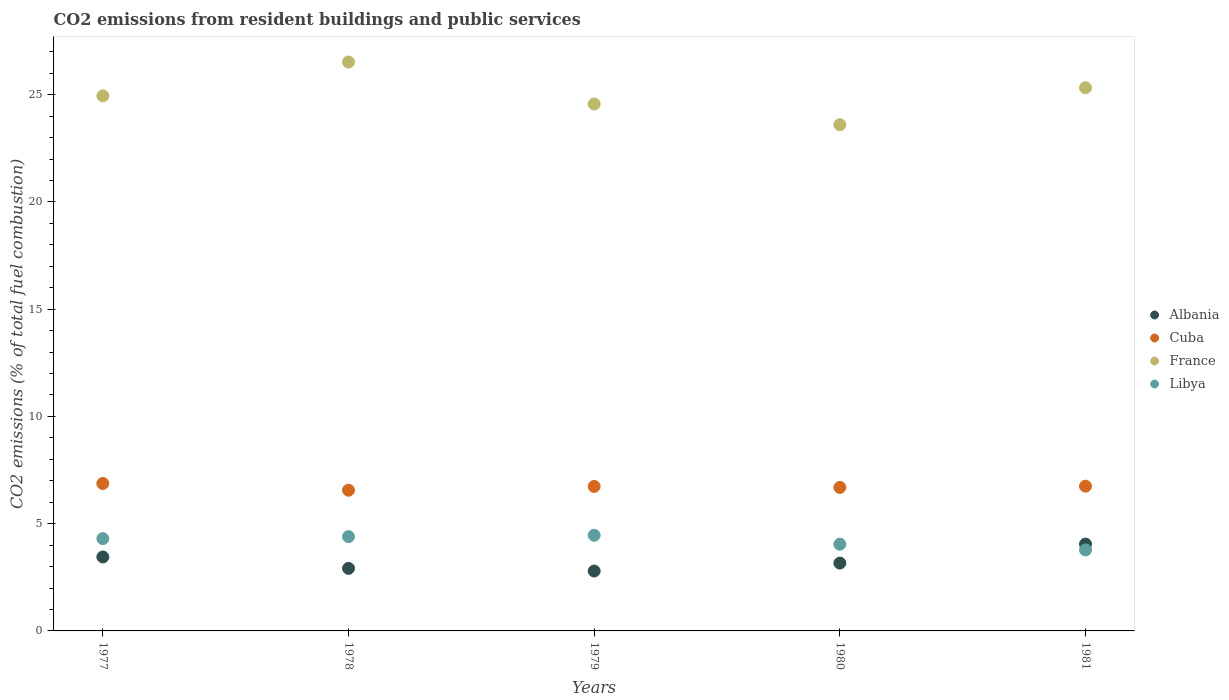Is the number of dotlines equal to the number of legend labels?
Keep it short and to the point. Yes. What is the total CO2 emitted in Cuba in 1979?
Your response must be concise. 6.74. Across all years, what is the maximum total CO2 emitted in Albania?
Offer a terse response. 4.05. Across all years, what is the minimum total CO2 emitted in Albania?
Provide a short and direct response. 2.79. In which year was the total CO2 emitted in France maximum?
Provide a succinct answer. 1978. In which year was the total CO2 emitted in Cuba minimum?
Offer a very short reply. 1978. What is the total total CO2 emitted in Libya in the graph?
Keep it short and to the point. 20.98. What is the difference between the total CO2 emitted in Libya in 1979 and that in 1980?
Ensure brevity in your answer.  0.42. What is the difference between the total CO2 emitted in Libya in 1981 and the total CO2 emitted in Albania in 1980?
Ensure brevity in your answer.  0.61. What is the average total CO2 emitted in France per year?
Your response must be concise. 24.99. In the year 1978, what is the difference between the total CO2 emitted in Albania and total CO2 emitted in Cuba?
Make the answer very short. -3.64. What is the ratio of the total CO2 emitted in France in 1979 to that in 1980?
Offer a very short reply. 1.04. What is the difference between the highest and the second highest total CO2 emitted in Libya?
Make the answer very short. 0.06. What is the difference between the highest and the lowest total CO2 emitted in Libya?
Your answer should be compact. 0.68. In how many years, is the total CO2 emitted in Libya greater than the average total CO2 emitted in Libya taken over all years?
Offer a terse response. 3. Is the sum of the total CO2 emitted in Cuba in 1979 and 1980 greater than the maximum total CO2 emitted in France across all years?
Your answer should be very brief. No. Does the total CO2 emitted in Albania monotonically increase over the years?
Give a very brief answer. No. How many dotlines are there?
Keep it short and to the point. 4. How many years are there in the graph?
Offer a terse response. 5. Are the values on the major ticks of Y-axis written in scientific E-notation?
Your answer should be compact. No. Does the graph contain any zero values?
Make the answer very short. No. How many legend labels are there?
Your answer should be compact. 4. How are the legend labels stacked?
Ensure brevity in your answer.  Vertical. What is the title of the graph?
Provide a short and direct response. CO2 emissions from resident buildings and public services. What is the label or title of the Y-axis?
Give a very brief answer. CO2 emissions (% of total fuel combustion). What is the CO2 emissions (% of total fuel combustion) of Albania in 1977?
Keep it short and to the point. 3.45. What is the CO2 emissions (% of total fuel combustion) of Cuba in 1977?
Keep it short and to the point. 6.88. What is the CO2 emissions (% of total fuel combustion) in France in 1977?
Your answer should be very brief. 24.95. What is the CO2 emissions (% of total fuel combustion) of Libya in 1977?
Make the answer very short. 4.3. What is the CO2 emissions (% of total fuel combustion) of Albania in 1978?
Your answer should be compact. 2.92. What is the CO2 emissions (% of total fuel combustion) in Cuba in 1978?
Provide a short and direct response. 6.56. What is the CO2 emissions (% of total fuel combustion) in France in 1978?
Your answer should be compact. 26.52. What is the CO2 emissions (% of total fuel combustion) of Libya in 1978?
Keep it short and to the point. 4.39. What is the CO2 emissions (% of total fuel combustion) of Albania in 1979?
Offer a very short reply. 2.79. What is the CO2 emissions (% of total fuel combustion) of Cuba in 1979?
Ensure brevity in your answer.  6.74. What is the CO2 emissions (% of total fuel combustion) of France in 1979?
Offer a terse response. 24.57. What is the CO2 emissions (% of total fuel combustion) in Libya in 1979?
Your answer should be very brief. 4.46. What is the CO2 emissions (% of total fuel combustion) in Albania in 1980?
Ensure brevity in your answer.  3.16. What is the CO2 emissions (% of total fuel combustion) of Cuba in 1980?
Ensure brevity in your answer.  6.69. What is the CO2 emissions (% of total fuel combustion) of France in 1980?
Ensure brevity in your answer.  23.6. What is the CO2 emissions (% of total fuel combustion) in Libya in 1980?
Offer a terse response. 4.04. What is the CO2 emissions (% of total fuel combustion) in Albania in 1981?
Make the answer very short. 4.05. What is the CO2 emissions (% of total fuel combustion) in Cuba in 1981?
Offer a terse response. 6.75. What is the CO2 emissions (% of total fuel combustion) in France in 1981?
Offer a terse response. 25.33. What is the CO2 emissions (% of total fuel combustion) of Libya in 1981?
Keep it short and to the point. 3.78. Across all years, what is the maximum CO2 emissions (% of total fuel combustion) in Albania?
Your answer should be very brief. 4.05. Across all years, what is the maximum CO2 emissions (% of total fuel combustion) of Cuba?
Provide a succinct answer. 6.88. Across all years, what is the maximum CO2 emissions (% of total fuel combustion) in France?
Give a very brief answer. 26.52. Across all years, what is the maximum CO2 emissions (% of total fuel combustion) of Libya?
Ensure brevity in your answer.  4.46. Across all years, what is the minimum CO2 emissions (% of total fuel combustion) in Albania?
Your answer should be compact. 2.79. Across all years, what is the minimum CO2 emissions (% of total fuel combustion) of Cuba?
Your answer should be very brief. 6.56. Across all years, what is the minimum CO2 emissions (% of total fuel combustion) of France?
Your answer should be compact. 23.6. Across all years, what is the minimum CO2 emissions (% of total fuel combustion) in Libya?
Your answer should be very brief. 3.78. What is the total CO2 emissions (% of total fuel combustion) in Albania in the graph?
Your answer should be compact. 16.37. What is the total CO2 emissions (% of total fuel combustion) in Cuba in the graph?
Make the answer very short. 33.61. What is the total CO2 emissions (% of total fuel combustion) of France in the graph?
Your answer should be very brief. 124.97. What is the total CO2 emissions (% of total fuel combustion) of Libya in the graph?
Give a very brief answer. 20.98. What is the difference between the CO2 emissions (% of total fuel combustion) of Albania in 1977 and that in 1978?
Provide a short and direct response. 0.53. What is the difference between the CO2 emissions (% of total fuel combustion) in Cuba in 1977 and that in 1978?
Your answer should be very brief. 0.31. What is the difference between the CO2 emissions (% of total fuel combustion) in France in 1977 and that in 1978?
Offer a terse response. -1.58. What is the difference between the CO2 emissions (% of total fuel combustion) of Libya in 1977 and that in 1978?
Your response must be concise. -0.09. What is the difference between the CO2 emissions (% of total fuel combustion) in Albania in 1977 and that in 1979?
Offer a terse response. 0.66. What is the difference between the CO2 emissions (% of total fuel combustion) of Cuba in 1977 and that in 1979?
Offer a very short reply. 0.14. What is the difference between the CO2 emissions (% of total fuel combustion) of France in 1977 and that in 1979?
Give a very brief answer. 0.38. What is the difference between the CO2 emissions (% of total fuel combustion) in Libya in 1977 and that in 1979?
Offer a very short reply. -0.16. What is the difference between the CO2 emissions (% of total fuel combustion) of Albania in 1977 and that in 1980?
Ensure brevity in your answer.  0.29. What is the difference between the CO2 emissions (% of total fuel combustion) of Cuba in 1977 and that in 1980?
Your answer should be compact. 0.18. What is the difference between the CO2 emissions (% of total fuel combustion) of France in 1977 and that in 1980?
Offer a terse response. 1.34. What is the difference between the CO2 emissions (% of total fuel combustion) of Libya in 1977 and that in 1980?
Provide a succinct answer. 0.26. What is the difference between the CO2 emissions (% of total fuel combustion) in Albania in 1977 and that in 1981?
Provide a short and direct response. -0.6. What is the difference between the CO2 emissions (% of total fuel combustion) in Cuba in 1977 and that in 1981?
Keep it short and to the point. 0.13. What is the difference between the CO2 emissions (% of total fuel combustion) in France in 1977 and that in 1981?
Offer a very short reply. -0.38. What is the difference between the CO2 emissions (% of total fuel combustion) in Libya in 1977 and that in 1981?
Your answer should be compact. 0.53. What is the difference between the CO2 emissions (% of total fuel combustion) of Albania in 1978 and that in 1979?
Offer a very short reply. 0.12. What is the difference between the CO2 emissions (% of total fuel combustion) of Cuba in 1978 and that in 1979?
Your response must be concise. -0.18. What is the difference between the CO2 emissions (% of total fuel combustion) of France in 1978 and that in 1979?
Provide a succinct answer. 1.96. What is the difference between the CO2 emissions (% of total fuel combustion) in Libya in 1978 and that in 1979?
Your response must be concise. -0.06. What is the difference between the CO2 emissions (% of total fuel combustion) of Albania in 1978 and that in 1980?
Your answer should be very brief. -0.24. What is the difference between the CO2 emissions (% of total fuel combustion) in Cuba in 1978 and that in 1980?
Provide a succinct answer. -0.13. What is the difference between the CO2 emissions (% of total fuel combustion) in France in 1978 and that in 1980?
Your response must be concise. 2.92. What is the difference between the CO2 emissions (% of total fuel combustion) of Libya in 1978 and that in 1980?
Your response must be concise. 0.35. What is the difference between the CO2 emissions (% of total fuel combustion) in Albania in 1978 and that in 1981?
Your answer should be compact. -1.13. What is the difference between the CO2 emissions (% of total fuel combustion) of Cuba in 1978 and that in 1981?
Your response must be concise. -0.19. What is the difference between the CO2 emissions (% of total fuel combustion) in France in 1978 and that in 1981?
Offer a very short reply. 1.2. What is the difference between the CO2 emissions (% of total fuel combustion) of Libya in 1978 and that in 1981?
Offer a very short reply. 0.62. What is the difference between the CO2 emissions (% of total fuel combustion) in Albania in 1979 and that in 1980?
Your response must be concise. -0.37. What is the difference between the CO2 emissions (% of total fuel combustion) of Cuba in 1979 and that in 1980?
Your response must be concise. 0.05. What is the difference between the CO2 emissions (% of total fuel combustion) of France in 1979 and that in 1980?
Offer a very short reply. 0.96. What is the difference between the CO2 emissions (% of total fuel combustion) in Libya in 1979 and that in 1980?
Provide a succinct answer. 0.42. What is the difference between the CO2 emissions (% of total fuel combustion) of Albania in 1979 and that in 1981?
Keep it short and to the point. -1.26. What is the difference between the CO2 emissions (% of total fuel combustion) of Cuba in 1979 and that in 1981?
Keep it short and to the point. -0.01. What is the difference between the CO2 emissions (% of total fuel combustion) of France in 1979 and that in 1981?
Offer a terse response. -0.76. What is the difference between the CO2 emissions (% of total fuel combustion) in Libya in 1979 and that in 1981?
Your answer should be compact. 0.68. What is the difference between the CO2 emissions (% of total fuel combustion) of Albania in 1980 and that in 1981?
Offer a very short reply. -0.89. What is the difference between the CO2 emissions (% of total fuel combustion) of Cuba in 1980 and that in 1981?
Ensure brevity in your answer.  -0.06. What is the difference between the CO2 emissions (% of total fuel combustion) of France in 1980 and that in 1981?
Offer a very short reply. -1.72. What is the difference between the CO2 emissions (% of total fuel combustion) of Libya in 1980 and that in 1981?
Provide a succinct answer. 0.27. What is the difference between the CO2 emissions (% of total fuel combustion) in Albania in 1977 and the CO2 emissions (% of total fuel combustion) in Cuba in 1978?
Ensure brevity in your answer.  -3.11. What is the difference between the CO2 emissions (% of total fuel combustion) of Albania in 1977 and the CO2 emissions (% of total fuel combustion) of France in 1978?
Ensure brevity in your answer.  -23.08. What is the difference between the CO2 emissions (% of total fuel combustion) of Albania in 1977 and the CO2 emissions (% of total fuel combustion) of Libya in 1978?
Keep it short and to the point. -0.95. What is the difference between the CO2 emissions (% of total fuel combustion) in Cuba in 1977 and the CO2 emissions (% of total fuel combustion) in France in 1978?
Keep it short and to the point. -19.65. What is the difference between the CO2 emissions (% of total fuel combustion) of Cuba in 1977 and the CO2 emissions (% of total fuel combustion) of Libya in 1978?
Give a very brief answer. 2.48. What is the difference between the CO2 emissions (% of total fuel combustion) of France in 1977 and the CO2 emissions (% of total fuel combustion) of Libya in 1978?
Give a very brief answer. 20.55. What is the difference between the CO2 emissions (% of total fuel combustion) in Albania in 1977 and the CO2 emissions (% of total fuel combustion) in Cuba in 1979?
Your answer should be compact. -3.29. What is the difference between the CO2 emissions (% of total fuel combustion) of Albania in 1977 and the CO2 emissions (% of total fuel combustion) of France in 1979?
Provide a short and direct response. -21.12. What is the difference between the CO2 emissions (% of total fuel combustion) in Albania in 1977 and the CO2 emissions (% of total fuel combustion) in Libya in 1979?
Provide a succinct answer. -1.01. What is the difference between the CO2 emissions (% of total fuel combustion) in Cuba in 1977 and the CO2 emissions (% of total fuel combustion) in France in 1979?
Make the answer very short. -17.69. What is the difference between the CO2 emissions (% of total fuel combustion) in Cuba in 1977 and the CO2 emissions (% of total fuel combustion) in Libya in 1979?
Provide a short and direct response. 2.42. What is the difference between the CO2 emissions (% of total fuel combustion) of France in 1977 and the CO2 emissions (% of total fuel combustion) of Libya in 1979?
Your answer should be compact. 20.49. What is the difference between the CO2 emissions (% of total fuel combustion) of Albania in 1977 and the CO2 emissions (% of total fuel combustion) of Cuba in 1980?
Your answer should be compact. -3.24. What is the difference between the CO2 emissions (% of total fuel combustion) in Albania in 1977 and the CO2 emissions (% of total fuel combustion) in France in 1980?
Offer a terse response. -20.15. What is the difference between the CO2 emissions (% of total fuel combustion) of Albania in 1977 and the CO2 emissions (% of total fuel combustion) of Libya in 1980?
Give a very brief answer. -0.59. What is the difference between the CO2 emissions (% of total fuel combustion) of Cuba in 1977 and the CO2 emissions (% of total fuel combustion) of France in 1980?
Offer a very short reply. -16.73. What is the difference between the CO2 emissions (% of total fuel combustion) in Cuba in 1977 and the CO2 emissions (% of total fuel combustion) in Libya in 1980?
Make the answer very short. 2.83. What is the difference between the CO2 emissions (% of total fuel combustion) in France in 1977 and the CO2 emissions (% of total fuel combustion) in Libya in 1980?
Offer a terse response. 20.9. What is the difference between the CO2 emissions (% of total fuel combustion) of Albania in 1977 and the CO2 emissions (% of total fuel combustion) of Cuba in 1981?
Ensure brevity in your answer.  -3.3. What is the difference between the CO2 emissions (% of total fuel combustion) in Albania in 1977 and the CO2 emissions (% of total fuel combustion) in France in 1981?
Keep it short and to the point. -21.88. What is the difference between the CO2 emissions (% of total fuel combustion) in Albania in 1977 and the CO2 emissions (% of total fuel combustion) in Libya in 1981?
Provide a succinct answer. -0.33. What is the difference between the CO2 emissions (% of total fuel combustion) in Cuba in 1977 and the CO2 emissions (% of total fuel combustion) in France in 1981?
Your answer should be very brief. -18.45. What is the difference between the CO2 emissions (% of total fuel combustion) in Cuba in 1977 and the CO2 emissions (% of total fuel combustion) in Libya in 1981?
Provide a short and direct response. 3.1. What is the difference between the CO2 emissions (% of total fuel combustion) of France in 1977 and the CO2 emissions (% of total fuel combustion) of Libya in 1981?
Keep it short and to the point. 21.17. What is the difference between the CO2 emissions (% of total fuel combustion) in Albania in 1978 and the CO2 emissions (% of total fuel combustion) in Cuba in 1979?
Keep it short and to the point. -3.82. What is the difference between the CO2 emissions (% of total fuel combustion) in Albania in 1978 and the CO2 emissions (% of total fuel combustion) in France in 1979?
Offer a very short reply. -21.65. What is the difference between the CO2 emissions (% of total fuel combustion) in Albania in 1978 and the CO2 emissions (% of total fuel combustion) in Libya in 1979?
Offer a very short reply. -1.54. What is the difference between the CO2 emissions (% of total fuel combustion) in Cuba in 1978 and the CO2 emissions (% of total fuel combustion) in France in 1979?
Make the answer very short. -18.01. What is the difference between the CO2 emissions (% of total fuel combustion) of Cuba in 1978 and the CO2 emissions (% of total fuel combustion) of Libya in 1979?
Your answer should be very brief. 2.1. What is the difference between the CO2 emissions (% of total fuel combustion) of France in 1978 and the CO2 emissions (% of total fuel combustion) of Libya in 1979?
Make the answer very short. 22.07. What is the difference between the CO2 emissions (% of total fuel combustion) of Albania in 1978 and the CO2 emissions (% of total fuel combustion) of Cuba in 1980?
Offer a terse response. -3.77. What is the difference between the CO2 emissions (% of total fuel combustion) in Albania in 1978 and the CO2 emissions (% of total fuel combustion) in France in 1980?
Your answer should be very brief. -20.69. What is the difference between the CO2 emissions (% of total fuel combustion) of Albania in 1978 and the CO2 emissions (% of total fuel combustion) of Libya in 1980?
Your answer should be very brief. -1.13. What is the difference between the CO2 emissions (% of total fuel combustion) in Cuba in 1978 and the CO2 emissions (% of total fuel combustion) in France in 1980?
Your response must be concise. -17.04. What is the difference between the CO2 emissions (% of total fuel combustion) of Cuba in 1978 and the CO2 emissions (% of total fuel combustion) of Libya in 1980?
Offer a terse response. 2.52. What is the difference between the CO2 emissions (% of total fuel combustion) of France in 1978 and the CO2 emissions (% of total fuel combustion) of Libya in 1980?
Provide a short and direct response. 22.48. What is the difference between the CO2 emissions (% of total fuel combustion) in Albania in 1978 and the CO2 emissions (% of total fuel combustion) in Cuba in 1981?
Provide a short and direct response. -3.83. What is the difference between the CO2 emissions (% of total fuel combustion) of Albania in 1978 and the CO2 emissions (% of total fuel combustion) of France in 1981?
Provide a succinct answer. -22.41. What is the difference between the CO2 emissions (% of total fuel combustion) in Albania in 1978 and the CO2 emissions (% of total fuel combustion) in Libya in 1981?
Keep it short and to the point. -0.86. What is the difference between the CO2 emissions (% of total fuel combustion) in Cuba in 1978 and the CO2 emissions (% of total fuel combustion) in France in 1981?
Offer a very short reply. -18.77. What is the difference between the CO2 emissions (% of total fuel combustion) of Cuba in 1978 and the CO2 emissions (% of total fuel combustion) of Libya in 1981?
Provide a short and direct response. 2.78. What is the difference between the CO2 emissions (% of total fuel combustion) in France in 1978 and the CO2 emissions (% of total fuel combustion) in Libya in 1981?
Offer a very short reply. 22.75. What is the difference between the CO2 emissions (% of total fuel combustion) of Albania in 1979 and the CO2 emissions (% of total fuel combustion) of Cuba in 1980?
Your answer should be very brief. -3.9. What is the difference between the CO2 emissions (% of total fuel combustion) in Albania in 1979 and the CO2 emissions (% of total fuel combustion) in France in 1980?
Your response must be concise. -20.81. What is the difference between the CO2 emissions (% of total fuel combustion) of Albania in 1979 and the CO2 emissions (% of total fuel combustion) of Libya in 1980?
Offer a very short reply. -1.25. What is the difference between the CO2 emissions (% of total fuel combustion) in Cuba in 1979 and the CO2 emissions (% of total fuel combustion) in France in 1980?
Provide a succinct answer. -16.87. What is the difference between the CO2 emissions (% of total fuel combustion) in Cuba in 1979 and the CO2 emissions (% of total fuel combustion) in Libya in 1980?
Offer a very short reply. 2.69. What is the difference between the CO2 emissions (% of total fuel combustion) in France in 1979 and the CO2 emissions (% of total fuel combustion) in Libya in 1980?
Provide a short and direct response. 20.52. What is the difference between the CO2 emissions (% of total fuel combustion) of Albania in 1979 and the CO2 emissions (% of total fuel combustion) of Cuba in 1981?
Provide a succinct answer. -3.96. What is the difference between the CO2 emissions (% of total fuel combustion) of Albania in 1979 and the CO2 emissions (% of total fuel combustion) of France in 1981?
Provide a short and direct response. -22.53. What is the difference between the CO2 emissions (% of total fuel combustion) of Albania in 1979 and the CO2 emissions (% of total fuel combustion) of Libya in 1981?
Ensure brevity in your answer.  -0.98. What is the difference between the CO2 emissions (% of total fuel combustion) in Cuba in 1979 and the CO2 emissions (% of total fuel combustion) in France in 1981?
Your response must be concise. -18.59. What is the difference between the CO2 emissions (% of total fuel combustion) in Cuba in 1979 and the CO2 emissions (% of total fuel combustion) in Libya in 1981?
Your answer should be compact. 2.96. What is the difference between the CO2 emissions (% of total fuel combustion) in France in 1979 and the CO2 emissions (% of total fuel combustion) in Libya in 1981?
Your answer should be compact. 20.79. What is the difference between the CO2 emissions (% of total fuel combustion) in Albania in 1980 and the CO2 emissions (% of total fuel combustion) in Cuba in 1981?
Give a very brief answer. -3.59. What is the difference between the CO2 emissions (% of total fuel combustion) of Albania in 1980 and the CO2 emissions (% of total fuel combustion) of France in 1981?
Your answer should be compact. -22.16. What is the difference between the CO2 emissions (% of total fuel combustion) of Albania in 1980 and the CO2 emissions (% of total fuel combustion) of Libya in 1981?
Make the answer very short. -0.61. What is the difference between the CO2 emissions (% of total fuel combustion) of Cuba in 1980 and the CO2 emissions (% of total fuel combustion) of France in 1981?
Offer a very short reply. -18.64. What is the difference between the CO2 emissions (% of total fuel combustion) in Cuba in 1980 and the CO2 emissions (% of total fuel combustion) in Libya in 1981?
Offer a terse response. 2.92. What is the difference between the CO2 emissions (% of total fuel combustion) of France in 1980 and the CO2 emissions (% of total fuel combustion) of Libya in 1981?
Your answer should be very brief. 19.83. What is the average CO2 emissions (% of total fuel combustion) of Albania per year?
Provide a succinct answer. 3.27. What is the average CO2 emissions (% of total fuel combustion) of Cuba per year?
Provide a succinct answer. 6.72. What is the average CO2 emissions (% of total fuel combustion) in France per year?
Provide a succinct answer. 24.99. What is the average CO2 emissions (% of total fuel combustion) of Libya per year?
Your answer should be compact. 4.2. In the year 1977, what is the difference between the CO2 emissions (% of total fuel combustion) of Albania and CO2 emissions (% of total fuel combustion) of Cuba?
Make the answer very short. -3.43. In the year 1977, what is the difference between the CO2 emissions (% of total fuel combustion) in Albania and CO2 emissions (% of total fuel combustion) in France?
Provide a succinct answer. -21.5. In the year 1977, what is the difference between the CO2 emissions (% of total fuel combustion) in Albania and CO2 emissions (% of total fuel combustion) in Libya?
Provide a succinct answer. -0.85. In the year 1977, what is the difference between the CO2 emissions (% of total fuel combustion) in Cuba and CO2 emissions (% of total fuel combustion) in France?
Offer a very short reply. -18.07. In the year 1977, what is the difference between the CO2 emissions (% of total fuel combustion) in Cuba and CO2 emissions (% of total fuel combustion) in Libya?
Make the answer very short. 2.57. In the year 1977, what is the difference between the CO2 emissions (% of total fuel combustion) of France and CO2 emissions (% of total fuel combustion) of Libya?
Your answer should be very brief. 20.64. In the year 1978, what is the difference between the CO2 emissions (% of total fuel combustion) of Albania and CO2 emissions (% of total fuel combustion) of Cuba?
Offer a terse response. -3.64. In the year 1978, what is the difference between the CO2 emissions (% of total fuel combustion) of Albania and CO2 emissions (% of total fuel combustion) of France?
Give a very brief answer. -23.61. In the year 1978, what is the difference between the CO2 emissions (% of total fuel combustion) of Albania and CO2 emissions (% of total fuel combustion) of Libya?
Offer a very short reply. -1.48. In the year 1978, what is the difference between the CO2 emissions (% of total fuel combustion) of Cuba and CO2 emissions (% of total fuel combustion) of France?
Your answer should be compact. -19.96. In the year 1978, what is the difference between the CO2 emissions (% of total fuel combustion) in Cuba and CO2 emissions (% of total fuel combustion) in Libya?
Give a very brief answer. 2.17. In the year 1978, what is the difference between the CO2 emissions (% of total fuel combustion) of France and CO2 emissions (% of total fuel combustion) of Libya?
Ensure brevity in your answer.  22.13. In the year 1979, what is the difference between the CO2 emissions (% of total fuel combustion) in Albania and CO2 emissions (% of total fuel combustion) in Cuba?
Provide a short and direct response. -3.94. In the year 1979, what is the difference between the CO2 emissions (% of total fuel combustion) in Albania and CO2 emissions (% of total fuel combustion) in France?
Give a very brief answer. -21.77. In the year 1979, what is the difference between the CO2 emissions (% of total fuel combustion) in Albania and CO2 emissions (% of total fuel combustion) in Libya?
Ensure brevity in your answer.  -1.67. In the year 1979, what is the difference between the CO2 emissions (% of total fuel combustion) of Cuba and CO2 emissions (% of total fuel combustion) of France?
Your answer should be compact. -17.83. In the year 1979, what is the difference between the CO2 emissions (% of total fuel combustion) of Cuba and CO2 emissions (% of total fuel combustion) of Libya?
Give a very brief answer. 2.28. In the year 1979, what is the difference between the CO2 emissions (% of total fuel combustion) of France and CO2 emissions (% of total fuel combustion) of Libya?
Ensure brevity in your answer.  20.11. In the year 1980, what is the difference between the CO2 emissions (% of total fuel combustion) of Albania and CO2 emissions (% of total fuel combustion) of Cuba?
Keep it short and to the point. -3.53. In the year 1980, what is the difference between the CO2 emissions (% of total fuel combustion) of Albania and CO2 emissions (% of total fuel combustion) of France?
Make the answer very short. -20.44. In the year 1980, what is the difference between the CO2 emissions (% of total fuel combustion) in Albania and CO2 emissions (% of total fuel combustion) in Libya?
Give a very brief answer. -0.88. In the year 1980, what is the difference between the CO2 emissions (% of total fuel combustion) in Cuba and CO2 emissions (% of total fuel combustion) in France?
Make the answer very short. -16.91. In the year 1980, what is the difference between the CO2 emissions (% of total fuel combustion) of Cuba and CO2 emissions (% of total fuel combustion) of Libya?
Your answer should be very brief. 2.65. In the year 1980, what is the difference between the CO2 emissions (% of total fuel combustion) of France and CO2 emissions (% of total fuel combustion) of Libya?
Provide a short and direct response. 19.56. In the year 1981, what is the difference between the CO2 emissions (% of total fuel combustion) in Albania and CO2 emissions (% of total fuel combustion) in Cuba?
Make the answer very short. -2.7. In the year 1981, what is the difference between the CO2 emissions (% of total fuel combustion) of Albania and CO2 emissions (% of total fuel combustion) of France?
Ensure brevity in your answer.  -21.28. In the year 1981, what is the difference between the CO2 emissions (% of total fuel combustion) in Albania and CO2 emissions (% of total fuel combustion) in Libya?
Make the answer very short. 0.27. In the year 1981, what is the difference between the CO2 emissions (% of total fuel combustion) of Cuba and CO2 emissions (% of total fuel combustion) of France?
Your answer should be very brief. -18.58. In the year 1981, what is the difference between the CO2 emissions (% of total fuel combustion) of Cuba and CO2 emissions (% of total fuel combustion) of Libya?
Keep it short and to the point. 2.97. In the year 1981, what is the difference between the CO2 emissions (% of total fuel combustion) of France and CO2 emissions (% of total fuel combustion) of Libya?
Your answer should be compact. 21.55. What is the ratio of the CO2 emissions (% of total fuel combustion) of Albania in 1977 to that in 1978?
Give a very brief answer. 1.18. What is the ratio of the CO2 emissions (% of total fuel combustion) of Cuba in 1977 to that in 1978?
Offer a very short reply. 1.05. What is the ratio of the CO2 emissions (% of total fuel combustion) in France in 1977 to that in 1978?
Provide a succinct answer. 0.94. What is the ratio of the CO2 emissions (% of total fuel combustion) in Libya in 1977 to that in 1978?
Offer a very short reply. 0.98. What is the ratio of the CO2 emissions (% of total fuel combustion) of Albania in 1977 to that in 1979?
Your answer should be compact. 1.23. What is the ratio of the CO2 emissions (% of total fuel combustion) of Cuba in 1977 to that in 1979?
Offer a very short reply. 1.02. What is the ratio of the CO2 emissions (% of total fuel combustion) of France in 1977 to that in 1979?
Your answer should be compact. 1.02. What is the ratio of the CO2 emissions (% of total fuel combustion) of Libya in 1977 to that in 1979?
Offer a terse response. 0.96. What is the ratio of the CO2 emissions (% of total fuel combustion) in Albania in 1977 to that in 1980?
Provide a succinct answer. 1.09. What is the ratio of the CO2 emissions (% of total fuel combustion) in Cuba in 1977 to that in 1980?
Give a very brief answer. 1.03. What is the ratio of the CO2 emissions (% of total fuel combustion) of France in 1977 to that in 1980?
Keep it short and to the point. 1.06. What is the ratio of the CO2 emissions (% of total fuel combustion) of Libya in 1977 to that in 1980?
Offer a terse response. 1.06. What is the ratio of the CO2 emissions (% of total fuel combustion) of Albania in 1977 to that in 1981?
Provide a succinct answer. 0.85. What is the ratio of the CO2 emissions (% of total fuel combustion) in Cuba in 1977 to that in 1981?
Make the answer very short. 1.02. What is the ratio of the CO2 emissions (% of total fuel combustion) of Libya in 1977 to that in 1981?
Your answer should be compact. 1.14. What is the ratio of the CO2 emissions (% of total fuel combustion) of Albania in 1978 to that in 1979?
Make the answer very short. 1.04. What is the ratio of the CO2 emissions (% of total fuel combustion) of Cuba in 1978 to that in 1979?
Offer a very short reply. 0.97. What is the ratio of the CO2 emissions (% of total fuel combustion) in France in 1978 to that in 1979?
Give a very brief answer. 1.08. What is the ratio of the CO2 emissions (% of total fuel combustion) of Libya in 1978 to that in 1979?
Provide a short and direct response. 0.99. What is the ratio of the CO2 emissions (% of total fuel combustion) of Albania in 1978 to that in 1980?
Offer a terse response. 0.92. What is the ratio of the CO2 emissions (% of total fuel combustion) in Cuba in 1978 to that in 1980?
Your response must be concise. 0.98. What is the ratio of the CO2 emissions (% of total fuel combustion) in France in 1978 to that in 1980?
Give a very brief answer. 1.12. What is the ratio of the CO2 emissions (% of total fuel combustion) in Libya in 1978 to that in 1980?
Offer a very short reply. 1.09. What is the ratio of the CO2 emissions (% of total fuel combustion) of Albania in 1978 to that in 1981?
Ensure brevity in your answer.  0.72. What is the ratio of the CO2 emissions (% of total fuel combustion) in Cuba in 1978 to that in 1981?
Provide a succinct answer. 0.97. What is the ratio of the CO2 emissions (% of total fuel combustion) in France in 1978 to that in 1981?
Make the answer very short. 1.05. What is the ratio of the CO2 emissions (% of total fuel combustion) in Libya in 1978 to that in 1981?
Provide a short and direct response. 1.16. What is the ratio of the CO2 emissions (% of total fuel combustion) in Albania in 1979 to that in 1980?
Keep it short and to the point. 0.88. What is the ratio of the CO2 emissions (% of total fuel combustion) of Cuba in 1979 to that in 1980?
Your response must be concise. 1.01. What is the ratio of the CO2 emissions (% of total fuel combustion) of France in 1979 to that in 1980?
Provide a succinct answer. 1.04. What is the ratio of the CO2 emissions (% of total fuel combustion) of Libya in 1979 to that in 1980?
Provide a succinct answer. 1.1. What is the ratio of the CO2 emissions (% of total fuel combustion) in Albania in 1979 to that in 1981?
Your answer should be very brief. 0.69. What is the ratio of the CO2 emissions (% of total fuel combustion) in Cuba in 1979 to that in 1981?
Offer a very short reply. 1. What is the ratio of the CO2 emissions (% of total fuel combustion) in France in 1979 to that in 1981?
Offer a very short reply. 0.97. What is the ratio of the CO2 emissions (% of total fuel combustion) of Libya in 1979 to that in 1981?
Provide a succinct answer. 1.18. What is the ratio of the CO2 emissions (% of total fuel combustion) of Albania in 1980 to that in 1981?
Your answer should be compact. 0.78. What is the ratio of the CO2 emissions (% of total fuel combustion) in Cuba in 1980 to that in 1981?
Offer a very short reply. 0.99. What is the ratio of the CO2 emissions (% of total fuel combustion) of France in 1980 to that in 1981?
Ensure brevity in your answer.  0.93. What is the ratio of the CO2 emissions (% of total fuel combustion) of Libya in 1980 to that in 1981?
Make the answer very short. 1.07. What is the difference between the highest and the second highest CO2 emissions (% of total fuel combustion) in Albania?
Give a very brief answer. 0.6. What is the difference between the highest and the second highest CO2 emissions (% of total fuel combustion) of Cuba?
Keep it short and to the point. 0.13. What is the difference between the highest and the second highest CO2 emissions (% of total fuel combustion) of France?
Keep it short and to the point. 1.2. What is the difference between the highest and the second highest CO2 emissions (% of total fuel combustion) of Libya?
Keep it short and to the point. 0.06. What is the difference between the highest and the lowest CO2 emissions (% of total fuel combustion) of Albania?
Offer a terse response. 1.26. What is the difference between the highest and the lowest CO2 emissions (% of total fuel combustion) in Cuba?
Offer a very short reply. 0.31. What is the difference between the highest and the lowest CO2 emissions (% of total fuel combustion) in France?
Provide a short and direct response. 2.92. What is the difference between the highest and the lowest CO2 emissions (% of total fuel combustion) in Libya?
Keep it short and to the point. 0.68. 